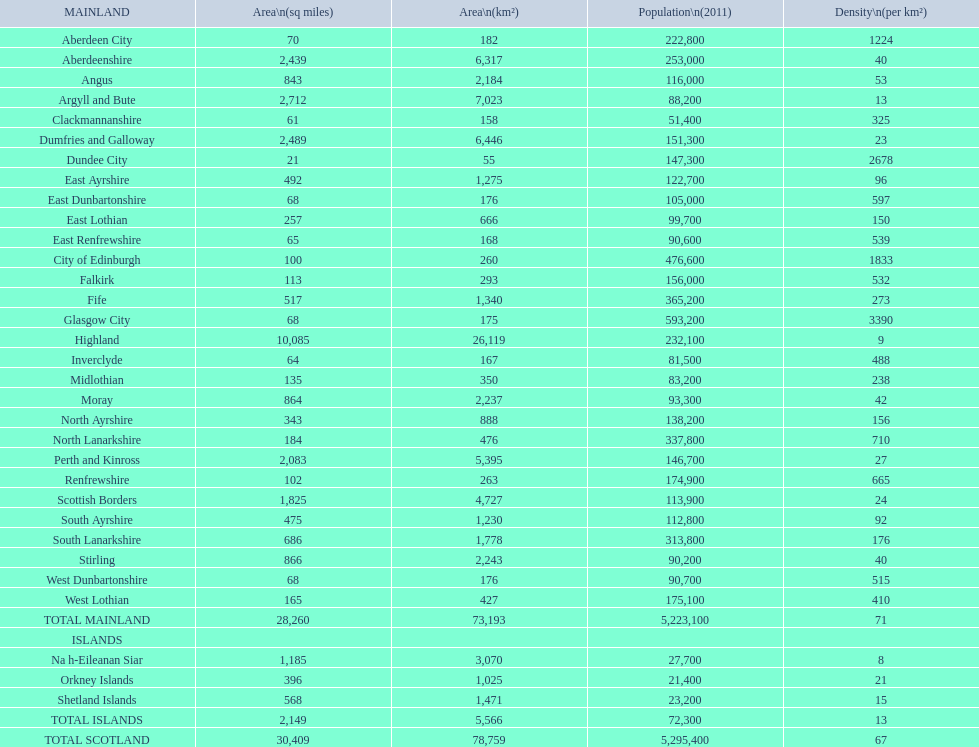In terms of area, which is the only subdivision that exceeds argyll and bute? Highland. 